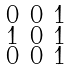Convert formula to latex. <formula><loc_0><loc_0><loc_500><loc_500>\begin{smallmatrix} 0 & 0 & 1 \\ 1 & 0 & 1 \\ 0 & 0 & 1 \end{smallmatrix}</formula> 